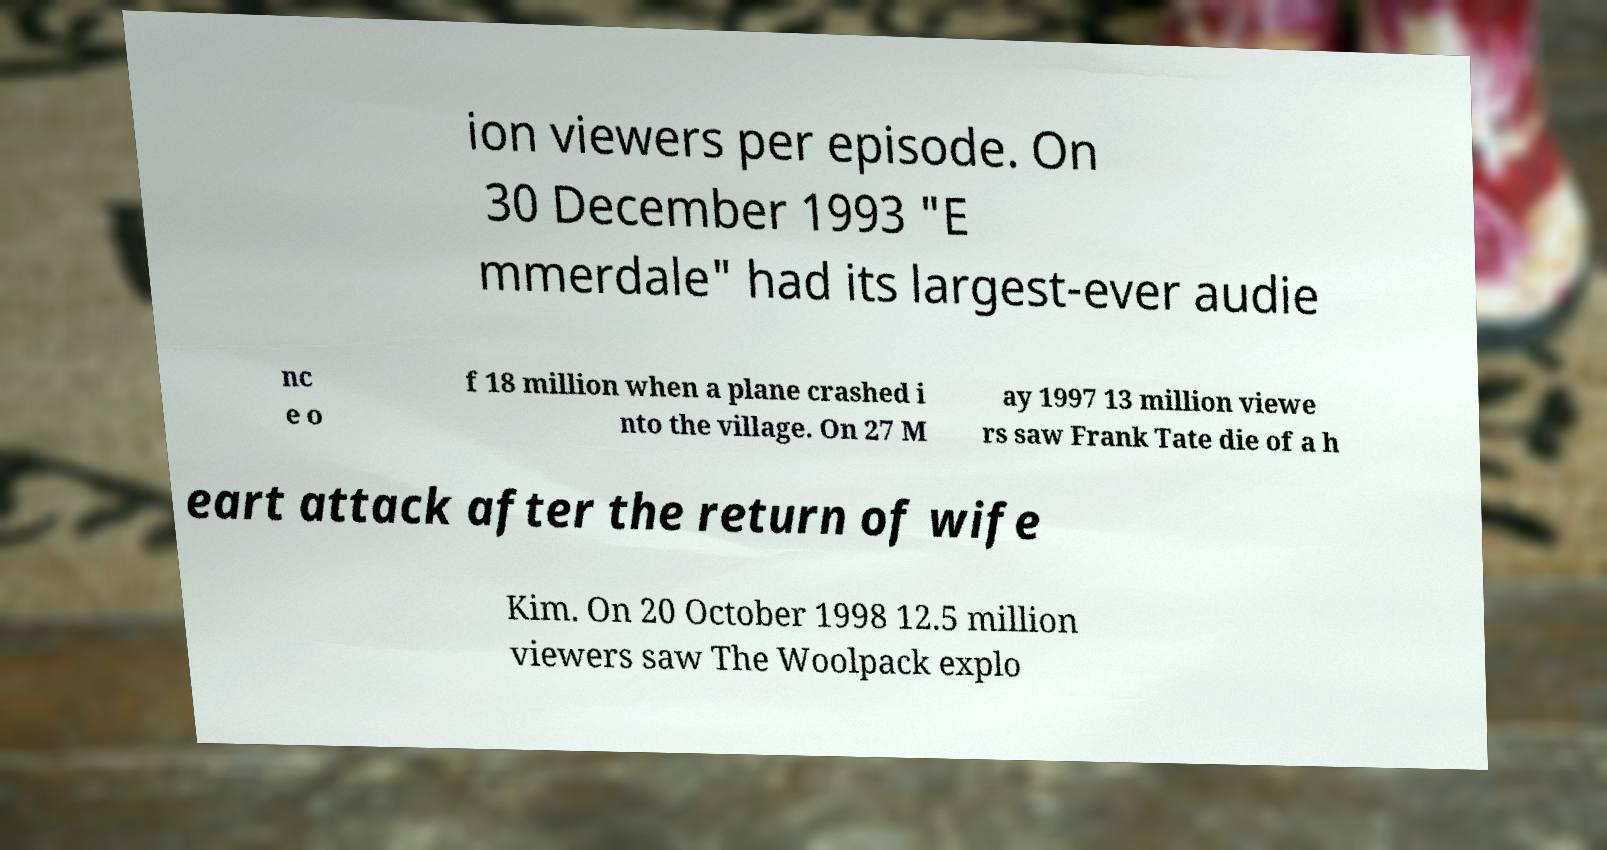Could you assist in decoding the text presented in this image and type it out clearly? ion viewers per episode. On 30 December 1993 "E mmerdale" had its largest-ever audie nc e o f 18 million when a plane crashed i nto the village. On 27 M ay 1997 13 million viewe rs saw Frank Tate die of a h eart attack after the return of wife Kim. On 20 October 1998 12.5 million viewers saw The Woolpack explo 